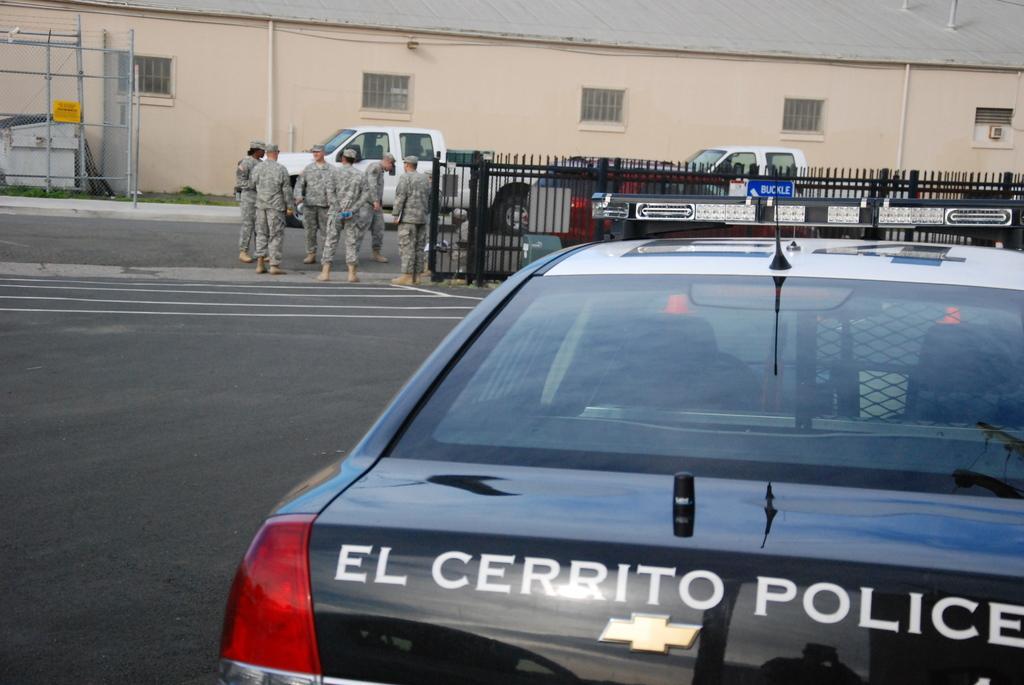Can you describe this image briefly? In the image there is a car on the right side of the road, in the middle there are few men standing beside a fence and over the back there is a building with some cars in front of it. 